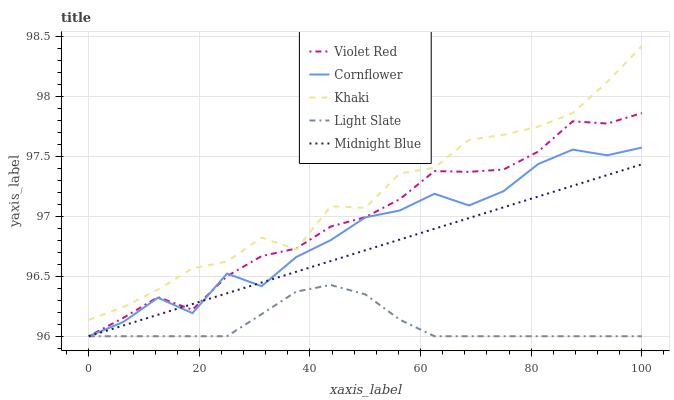Does Light Slate have the minimum area under the curve?
Answer yes or no. Yes. Does Khaki have the maximum area under the curve?
Answer yes or no. Yes. Does Cornflower have the minimum area under the curve?
Answer yes or no. No. Does Cornflower have the maximum area under the curve?
Answer yes or no. No. Is Midnight Blue the smoothest?
Answer yes or no. Yes. Is Cornflower the roughest?
Answer yes or no. Yes. Is Violet Red the smoothest?
Answer yes or no. No. Is Violet Red the roughest?
Answer yes or no. No. Does Light Slate have the lowest value?
Answer yes or no. Yes. Does Khaki have the lowest value?
Answer yes or no. No. Does Khaki have the highest value?
Answer yes or no. Yes. Does Cornflower have the highest value?
Answer yes or no. No. Is Light Slate less than Khaki?
Answer yes or no. Yes. Is Khaki greater than Light Slate?
Answer yes or no. Yes. Does Light Slate intersect Cornflower?
Answer yes or no. Yes. Is Light Slate less than Cornflower?
Answer yes or no. No. Is Light Slate greater than Cornflower?
Answer yes or no. No. Does Light Slate intersect Khaki?
Answer yes or no. No. 